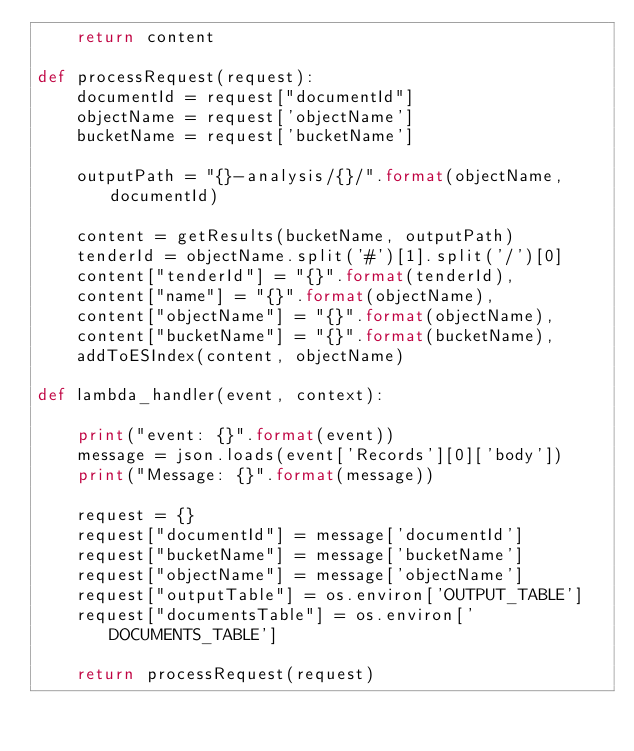Convert code to text. <code><loc_0><loc_0><loc_500><loc_500><_Python_>    return content

def processRequest(request):
    documentId = request["documentId"]
    objectName = request['objectName']
    bucketName = request['bucketName']
     
    outputPath = "{}-analysis/{}/".format(objectName, documentId)

    content = getResults(bucketName, outputPath)
    tenderId = objectName.split('#')[1].split('/')[0]
    content["tenderId"] = "{}".format(tenderId),
    content["name"] = "{}".format(objectName),
    content["objectName"] = "{}".format(objectName),
    content["bucketName"] = "{}".format(bucketName),
    addToESIndex(content, objectName)

def lambda_handler(event, context):

    print("event: {}".format(event))
    message = json.loads(event['Records'][0]['body'])
    print("Message: {}".format(message))

    request = {}
    request["documentId"] = message['documentId']
    request["bucketName"] = message['bucketName']
    request["objectName"] = message['objectName']
    request["outputTable"] = os.environ['OUTPUT_TABLE']
    request["documentsTable"] = os.environ['DOCUMENTS_TABLE']

    return processRequest(request)
</code> 